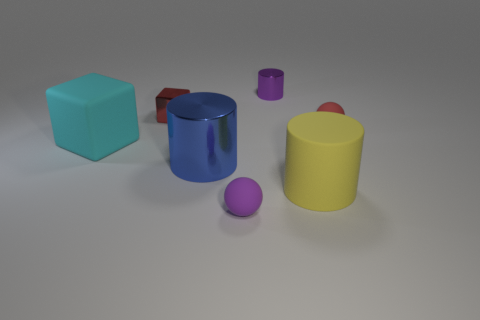Subtract all blue metallic cylinders. How many cylinders are left? 2 Subtract all red cubes. How many cubes are left? 1 Add 2 large objects. How many objects exist? 9 Subtract all blocks. How many objects are left? 5 Subtract 2 blocks. How many blocks are left? 0 Subtract all brown cylinders. How many cyan spheres are left? 0 Subtract all small things. Subtract all tiny red blocks. How many objects are left? 2 Add 7 small red rubber spheres. How many small red rubber spheres are left? 8 Add 1 small matte objects. How many small matte objects exist? 3 Subtract 0 green balls. How many objects are left? 7 